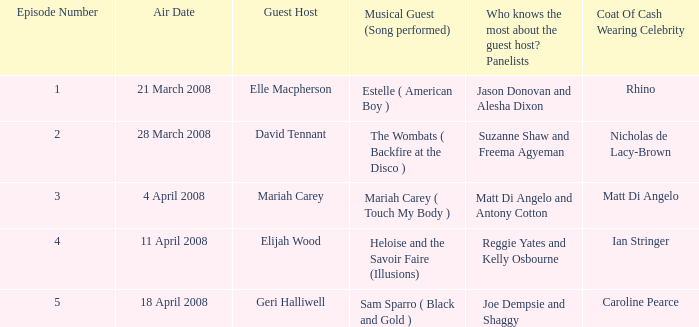Identify the musical guest when the guest host is elle macpherson. Estelle ( American Boy ). 